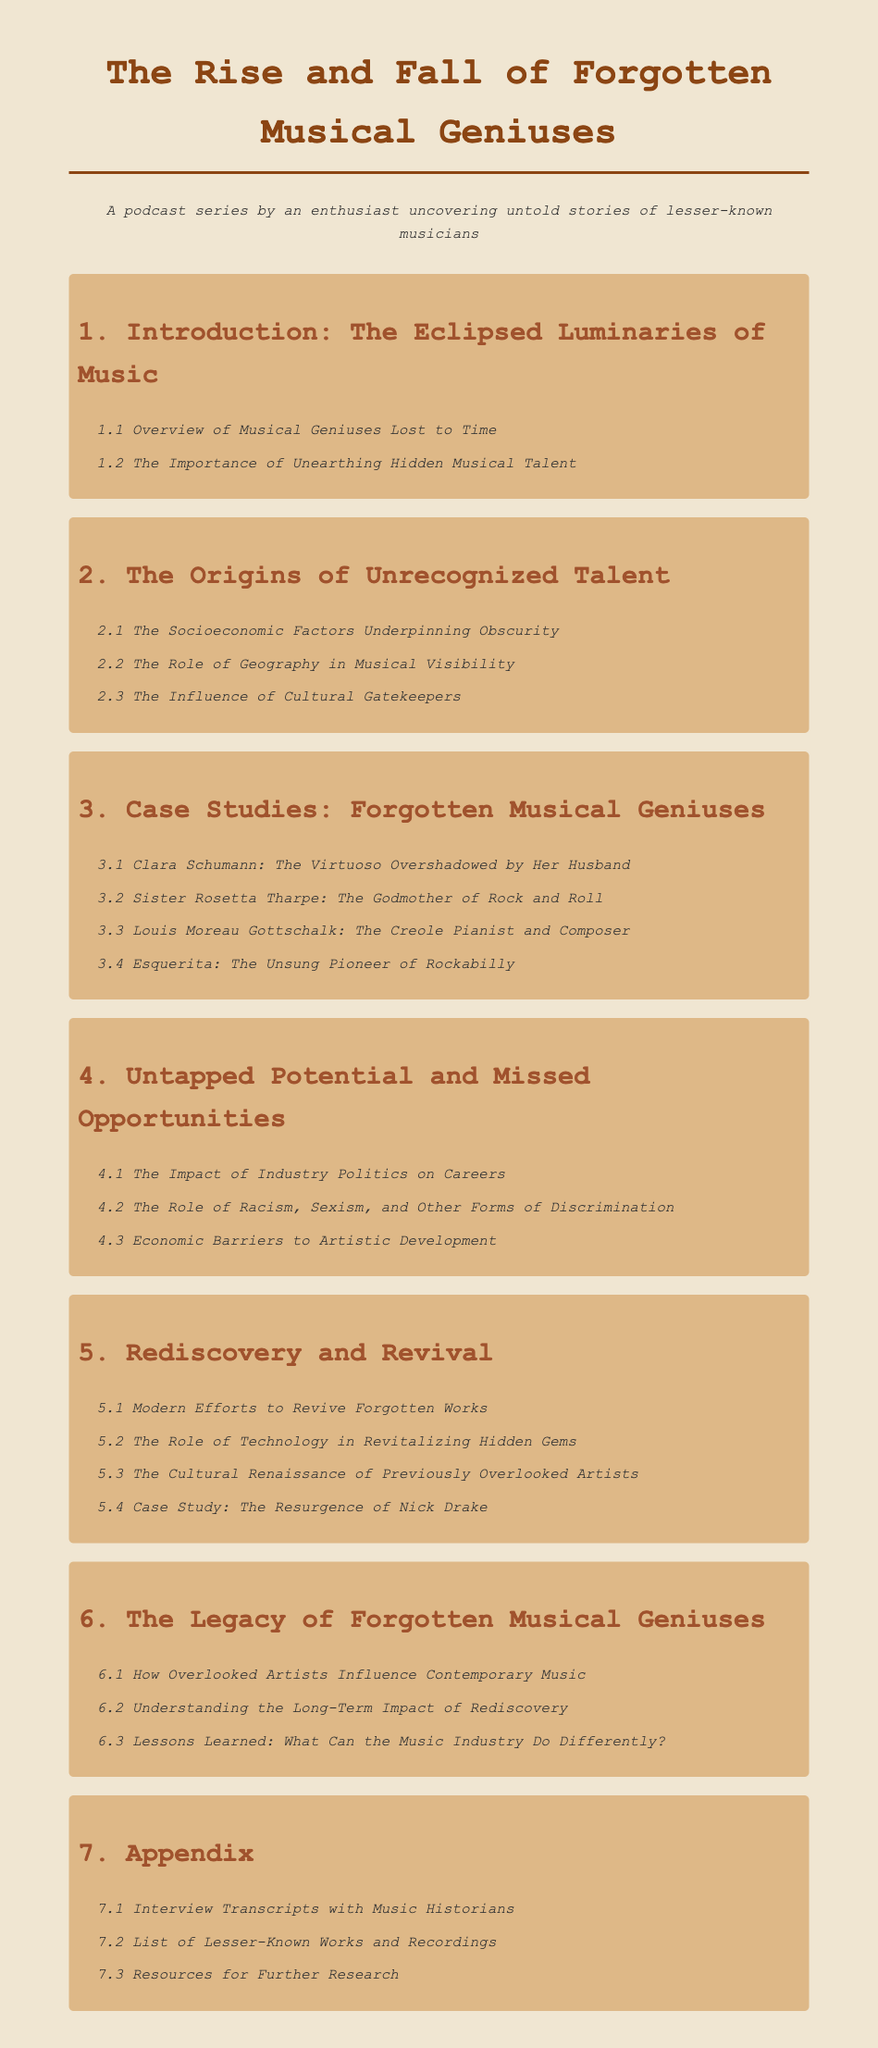what is the title of the podcast series? The title of the podcast series is the main heading of the document, which is prominently displayed at the top.
Answer: The Rise and Fall of Forgotten Musical Geniuses how many case studies are mentioned in the document? The number of case studies can be counted from the list under the "Case Studies: Forgotten Musical Geniuses" section.
Answer: 4 who is referred to as the Godmother of Rock and Roll? This title is given to one of the artists mentioned in the case studies section, indicating her significance in the music history.
Answer: Sister Rosetta Tharpe what is one of the socioeconomic factors discussed? This information can be found in the section that examines the origins of unrecognized talent, highlighting various influences on obscurity.
Answer: The Socioeconomic Factors Underpinning Obscurity which chapter discusses modern efforts to revive forgotten works? The chapter titles are clearly indicated in the document, and this specific topic is located in the section about rediscovery.
Answer: Chapter 5 how many sections are in the Legacy of Forgotten Musical Geniuses chapter? The number of sections can be counted from the list provided under the chapter discussing the legacy.
Answer: 3 what is the last section of the appendix? By checking the sections listed in the appendix, we can determine what content is covered last.
Answer: Resources for Further Research who is the case study mentioned for the resurgence? This is indicated in the rediscovery section regarding individual cases of revival.
Answer: Nick Drake 